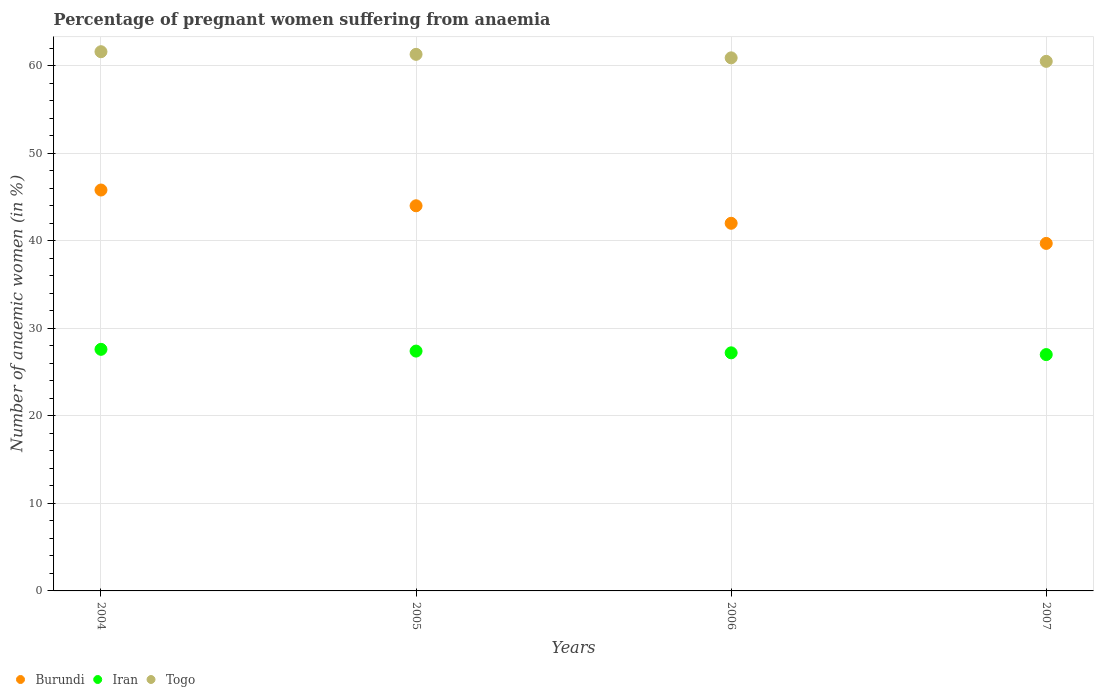Is the number of dotlines equal to the number of legend labels?
Give a very brief answer. Yes. What is the number of anaemic women in Iran in 2004?
Your answer should be compact. 27.6. Across all years, what is the maximum number of anaemic women in Burundi?
Your answer should be very brief. 45.8. Across all years, what is the minimum number of anaemic women in Burundi?
Provide a succinct answer. 39.7. In which year was the number of anaemic women in Iran maximum?
Offer a very short reply. 2004. In which year was the number of anaemic women in Iran minimum?
Ensure brevity in your answer.  2007. What is the total number of anaemic women in Togo in the graph?
Ensure brevity in your answer.  244.3. What is the difference between the number of anaemic women in Burundi in 2005 and that in 2006?
Your answer should be compact. 2. What is the average number of anaemic women in Togo per year?
Keep it short and to the point. 61.08. In the year 2006, what is the difference between the number of anaemic women in Burundi and number of anaemic women in Togo?
Your answer should be compact. -18.9. What is the ratio of the number of anaemic women in Iran in 2004 to that in 2007?
Your answer should be very brief. 1.02. Is the difference between the number of anaemic women in Burundi in 2004 and 2007 greater than the difference between the number of anaemic women in Togo in 2004 and 2007?
Your response must be concise. Yes. What is the difference between the highest and the second highest number of anaemic women in Togo?
Your answer should be compact. 0.3. What is the difference between the highest and the lowest number of anaemic women in Burundi?
Make the answer very short. 6.1. Is it the case that in every year, the sum of the number of anaemic women in Iran and number of anaemic women in Togo  is greater than the number of anaemic women in Burundi?
Make the answer very short. Yes. Does the number of anaemic women in Burundi monotonically increase over the years?
Ensure brevity in your answer.  No. Is the number of anaemic women in Togo strictly greater than the number of anaemic women in Burundi over the years?
Offer a very short reply. Yes. Is the number of anaemic women in Burundi strictly less than the number of anaemic women in Iran over the years?
Provide a short and direct response. No. How many years are there in the graph?
Offer a very short reply. 4. What is the difference between two consecutive major ticks on the Y-axis?
Offer a very short reply. 10. Are the values on the major ticks of Y-axis written in scientific E-notation?
Keep it short and to the point. No. Does the graph contain any zero values?
Your answer should be compact. No. How many legend labels are there?
Provide a succinct answer. 3. How are the legend labels stacked?
Make the answer very short. Horizontal. What is the title of the graph?
Offer a terse response. Percentage of pregnant women suffering from anaemia. Does "Andorra" appear as one of the legend labels in the graph?
Your answer should be compact. No. What is the label or title of the Y-axis?
Give a very brief answer. Number of anaemic women (in %). What is the Number of anaemic women (in %) in Burundi in 2004?
Provide a short and direct response. 45.8. What is the Number of anaemic women (in %) of Iran in 2004?
Keep it short and to the point. 27.6. What is the Number of anaemic women (in %) of Togo in 2004?
Provide a short and direct response. 61.6. What is the Number of anaemic women (in %) in Iran in 2005?
Your answer should be compact. 27.4. What is the Number of anaemic women (in %) of Togo in 2005?
Offer a very short reply. 61.3. What is the Number of anaemic women (in %) in Burundi in 2006?
Your response must be concise. 42. What is the Number of anaemic women (in %) in Iran in 2006?
Give a very brief answer. 27.2. What is the Number of anaemic women (in %) in Togo in 2006?
Offer a terse response. 60.9. What is the Number of anaemic women (in %) in Burundi in 2007?
Your answer should be compact. 39.7. What is the Number of anaemic women (in %) in Iran in 2007?
Keep it short and to the point. 27. What is the Number of anaemic women (in %) in Togo in 2007?
Make the answer very short. 60.5. Across all years, what is the maximum Number of anaemic women (in %) in Burundi?
Keep it short and to the point. 45.8. Across all years, what is the maximum Number of anaemic women (in %) of Iran?
Ensure brevity in your answer.  27.6. Across all years, what is the maximum Number of anaemic women (in %) of Togo?
Your answer should be compact. 61.6. Across all years, what is the minimum Number of anaemic women (in %) of Burundi?
Ensure brevity in your answer.  39.7. Across all years, what is the minimum Number of anaemic women (in %) of Iran?
Give a very brief answer. 27. Across all years, what is the minimum Number of anaemic women (in %) in Togo?
Your answer should be very brief. 60.5. What is the total Number of anaemic women (in %) of Burundi in the graph?
Your answer should be very brief. 171.5. What is the total Number of anaemic women (in %) in Iran in the graph?
Your response must be concise. 109.2. What is the total Number of anaemic women (in %) in Togo in the graph?
Offer a very short reply. 244.3. What is the difference between the Number of anaemic women (in %) in Iran in 2004 and that in 2005?
Your answer should be compact. 0.2. What is the difference between the Number of anaemic women (in %) in Burundi in 2004 and that in 2006?
Offer a terse response. 3.8. What is the difference between the Number of anaemic women (in %) in Iran in 2004 and that in 2006?
Your answer should be very brief. 0.4. What is the difference between the Number of anaemic women (in %) in Togo in 2004 and that in 2006?
Your answer should be very brief. 0.7. What is the difference between the Number of anaemic women (in %) in Iran in 2004 and that in 2007?
Offer a terse response. 0.6. What is the difference between the Number of anaemic women (in %) in Burundi in 2005 and that in 2006?
Keep it short and to the point. 2. What is the difference between the Number of anaemic women (in %) of Burundi in 2005 and that in 2007?
Make the answer very short. 4.3. What is the difference between the Number of anaemic women (in %) of Togo in 2005 and that in 2007?
Your response must be concise. 0.8. What is the difference between the Number of anaemic women (in %) of Iran in 2006 and that in 2007?
Offer a terse response. 0.2. What is the difference between the Number of anaemic women (in %) of Togo in 2006 and that in 2007?
Make the answer very short. 0.4. What is the difference between the Number of anaemic women (in %) of Burundi in 2004 and the Number of anaemic women (in %) of Togo in 2005?
Your answer should be compact. -15.5. What is the difference between the Number of anaemic women (in %) in Iran in 2004 and the Number of anaemic women (in %) in Togo in 2005?
Your response must be concise. -33.7. What is the difference between the Number of anaemic women (in %) of Burundi in 2004 and the Number of anaemic women (in %) of Togo in 2006?
Your answer should be compact. -15.1. What is the difference between the Number of anaemic women (in %) of Iran in 2004 and the Number of anaemic women (in %) of Togo in 2006?
Ensure brevity in your answer.  -33.3. What is the difference between the Number of anaemic women (in %) in Burundi in 2004 and the Number of anaemic women (in %) in Togo in 2007?
Give a very brief answer. -14.7. What is the difference between the Number of anaemic women (in %) in Iran in 2004 and the Number of anaemic women (in %) in Togo in 2007?
Offer a very short reply. -32.9. What is the difference between the Number of anaemic women (in %) of Burundi in 2005 and the Number of anaemic women (in %) of Iran in 2006?
Offer a very short reply. 16.8. What is the difference between the Number of anaemic women (in %) of Burundi in 2005 and the Number of anaemic women (in %) of Togo in 2006?
Offer a terse response. -16.9. What is the difference between the Number of anaemic women (in %) in Iran in 2005 and the Number of anaemic women (in %) in Togo in 2006?
Keep it short and to the point. -33.5. What is the difference between the Number of anaemic women (in %) in Burundi in 2005 and the Number of anaemic women (in %) in Togo in 2007?
Provide a short and direct response. -16.5. What is the difference between the Number of anaemic women (in %) in Iran in 2005 and the Number of anaemic women (in %) in Togo in 2007?
Provide a succinct answer. -33.1. What is the difference between the Number of anaemic women (in %) in Burundi in 2006 and the Number of anaemic women (in %) in Togo in 2007?
Make the answer very short. -18.5. What is the difference between the Number of anaemic women (in %) in Iran in 2006 and the Number of anaemic women (in %) in Togo in 2007?
Offer a very short reply. -33.3. What is the average Number of anaemic women (in %) in Burundi per year?
Give a very brief answer. 42.88. What is the average Number of anaemic women (in %) in Iran per year?
Provide a succinct answer. 27.3. What is the average Number of anaemic women (in %) of Togo per year?
Your response must be concise. 61.08. In the year 2004, what is the difference between the Number of anaemic women (in %) of Burundi and Number of anaemic women (in %) of Iran?
Your answer should be very brief. 18.2. In the year 2004, what is the difference between the Number of anaemic women (in %) of Burundi and Number of anaemic women (in %) of Togo?
Make the answer very short. -15.8. In the year 2004, what is the difference between the Number of anaemic women (in %) in Iran and Number of anaemic women (in %) in Togo?
Provide a short and direct response. -34. In the year 2005, what is the difference between the Number of anaemic women (in %) in Burundi and Number of anaemic women (in %) in Iran?
Your answer should be compact. 16.6. In the year 2005, what is the difference between the Number of anaemic women (in %) in Burundi and Number of anaemic women (in %) in Togo?
Offer a terse response. -17.3. In the year 2005, what is the difference between the Number of anaemic women (in %) of Iran and Number of anaemic women (in %) of Togo?
Make the answer very short. -33.9. In the year 2006, what is the difference between the Number of anaemic women (in %) in Burundi and Number of anaemic women (in %) in Togo?
Make the answer very short. -18.9. In the year 2006, what is the difference between the Number of anaemic women (in %) of Iran and Number of anaemic women (in %) of Togo?
Offer a very short reply. -33.7. In the year 2007, what is the difference between the Number of anaemic women (in %) of Burundi and Number of anaemic women (in %) of Togo?
Make the answer very short. -20.8. In the year 2007, what is the difference between the Number of anaemic women (in %) in Iran and Number of anaemic women (in %) in Togo?
Offer a very short reply. -33.5. What is the ratio of the Number of anaemic women (in %) in Burundi in 2004 to that in 2005?
Offer a very short reply. 1.04. What is the ratio of the Number of anaemic women (in %) in Iran in 2004 to that in 2005?
Give a very brief answer. 1.01. What is the ratio of the Number of anaemic women (in %) of Togo in 2004 to that in 2005?
Provide a short and direct response. 1. What is the ratio of the Number of anaemic women (in %) in Burundi in 2004 to that in 2006?
Give a very brief answer. 1.09. What is the ratio of the Number of anaemic women (in %) of Iran in 2004 to that in 2006?
Make the answer very short. 1.01. What is the ratio of the Number of anaemic women (in %) in Togo in 2004 to that in 2006?
Provide a succinct answer. 1.01. What is the ratio of the Number of anaemic women (in %) of Burundi in 2004 to that in 2007?
Provide a succinct answer. 1.15. What is the ratio of the Number of anaemic women (in %) of Iran in 2004 to that in 2007?
Provide a succinct answer. 1.02. What is the ratio of the Number of anaemic women (in %) of Togo in 2004 to that in 2007?
Your answer should be very brief. 1.02. What is the ratio of the Number of anaemic women (in %) in Burundi in 2005 to that in 2006?
Your answer should be very brief. 1.05. What is the ratio of the Number of anaemic women (in %) in Iran in 2005 to that in 2006?
Make the answer very short. 1.01. What is the ratio of the Number of anaemic women (in %) of Togo in 2005 to that in 2006?
Your answer should be compact. 1.01. What is the ratio of the Number of anaemic women (in %) of Burundi in 2005 to that in 2007?
Provide a short and direct response. 1.11. What is the ratio of the Number of anaemic women (in %) of Iran in 2005 to that in 2007?
Your answer should be compact. 1.01. What is the ratio of the Number of anaemic women (in %) in Togo in 2005 to that in 2007?
Ensure brevity in your answer.  1.01. What is the ratio of the Number of anaemic women (in %) in Burundi in 2006 to that in 2007?
Make the answer very short. 1.06. What is the ratio of the Number of anaemic women (in %) of Iran in 2006 to that in 2007?
Keep it short and to the point. 1.01. What is the ratio of the Number of anaemic women (in %) of Togo in 2006 to that in 2007?
Offer a terse response. 1.01. What is the difference between the highest and the second highest Number of anaemic women (in %) in Burundi?
Offer a very short reply. 1.8. What is the difference between the highest and the second highest Number of anaemic women (in %) of Iran?
Offer a very short reply. 0.2. What is the difference between the highest and the second highest Number of anaemic women (in %) of Togo?
Make the answer very short. 0.3. 